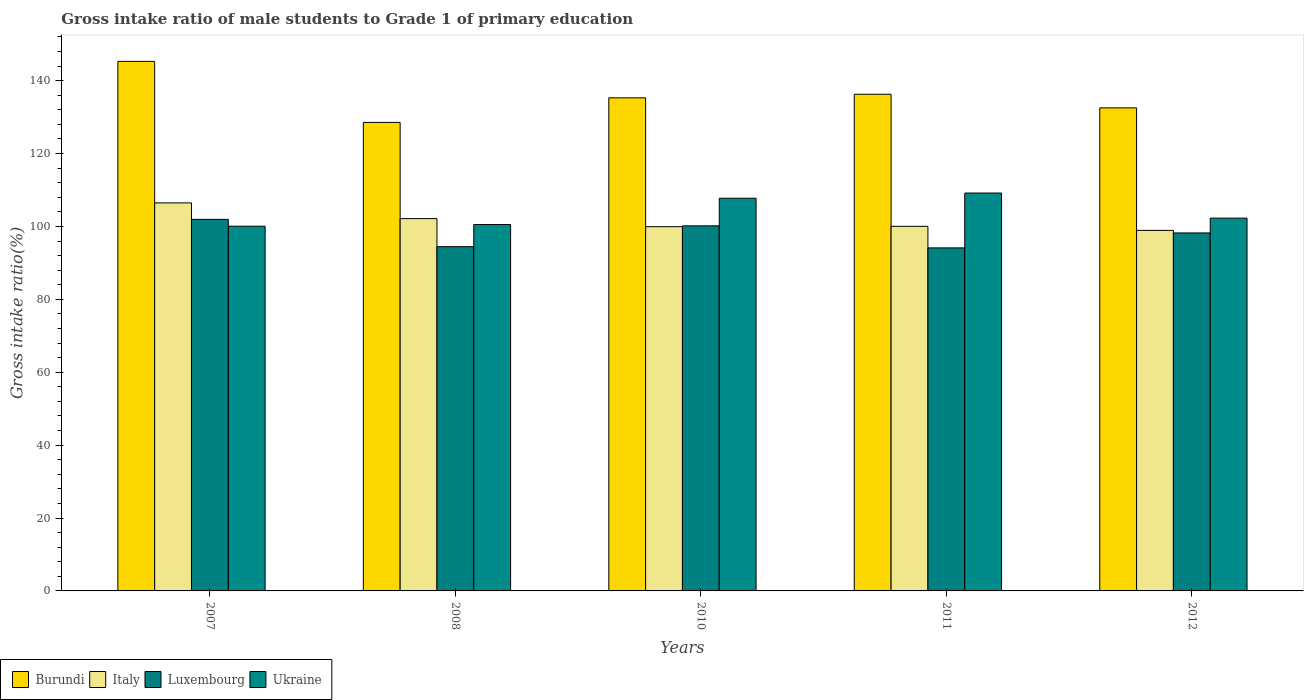How many different coloured bars are there?
Your answer should be very brief. 4. How many groups of bars are there?
Keep it short and to the point. 5. Are the number of bars on each tick of the X-axis equal?
Your answer should be compact. Yes. What is the label of the 5th group of bars from the left?
Your answer should be very brief. 2012. In how many cases, is the number of bars for a given year not equal to the number of legend labels?
Provide a succinct answer. 0. What is the gross intake ratio in Ukraine in 2012?
Give a very brief answer. 102.28. Across all years, what is the maximum gross intake ratio in Burundi?
Your answer should be compact. 145.3. Across all years, what is the minimum gross intake ratio in Burundi?
Make the answer very short. 128.55. In which year was the gross intake ratio in Ukraine maximum?
Offer a very short reply. 2011. In which year was the gross intake ratio in Burundi minimum?
Keep it short and to the point. 2008. What is the total gross intake ratio in Burundi in the graph?
Ensure brevity in your answer.  677.95. What is the difference between the gross intake ratio in Burundi in 2008 and that in 2011?
Offer a very short reply. -7.72. What is the difference between the gross intake ratio in Ukraine in 2008 and the gross intake ratio in Luxembourg in 2012?
Your answer should be compact. 2.3. What is the average gross intake ratio in Ukraine per year?
Your answer should be very brief. 103.96. In the year 2010, what is the difference between the gross intake ratio in Ukraine and gross intake ratio in Italy?
Offer a very short reply. 7.81. In how many years, is the gross intake ratio in Luxembourg greater than 52 %?
Offer a terse response. 5. What is the ratio of the gross intake ratio in Italy in 2010 to that in 2012?
Offer a terse response. 1.01. Is the difference between the gross intake ratio in Ukraine in 2011 and 2012 greater than the difference between the gross intake ratio in Italy in 2011 and 2012?
Provide a succinct answer. Yes. What is the difference between the highest and the second highest gross intake ratio in Burundi?
Your answer should be very brief. 9.03. What is the difference between the highest and the lowest gross intake ratio in Ukraine?
Your response must be concise. 9.1. What does the 2nd bar from the left in 2007 represents?
Provide a succinct answer. Italy. How many bars are there?
Keep it short and to the point. 20. What is the difference between two consecutive major ticks on the Y-axis?
Ensure brevity in your answer.  20. Are the values on the major ticks of Y-axis written in scientific E-notation?
Your answer should be very brief. No. Does the graph contain any zero values?
Make the answer very short. No. Where does the legend appear in the graph?
Your answer should be very brief. Bottom left. What is the title of the graph?
Offer a terse response. Gross intake ratio of male students to Grade 1 of primary education. What is the label or title of the Y-axis?
Give a very brief answer. Gross intake ratio(%). What is the Gross intake ratio(%) of Burundi in 2007?
Your answer should be compact. 145.3. What is the Gross intake ratio(%) in Italy in 2007?
Provide a short and direct response. 106.46. What is the Gross intake ratio(%) of Luxembourg in 2007?
Your answer should be compact. 101.94. What is the Gross intake ratio(%) of Ukraine in 2007?
Ensure brevity in your answer.  100.07. What is the Gross intake ratio(%) of Burundi in 2008?
Offer a terse response. 128.55. What is the Gross intake ratio(%) in Italy in 2008?
Offer a very short reply. 102.15. What is the Gross intake ratio(%) of Luxembourg in 2008?
Offer a very short reply. 94.45. What is the Gross intake ratio(%) in Ukraine in 2008?
Provide a succinct answer. 100.52. What is the Gross intake ratio(%) in Burundi in 2010?
Your response must be concise. 135.29. What is the Gross intake ratio(%) in Italy in 2010?
Provide a short and direct response. 99.94. What is the Gross intake ratio(%) of Luxembourg in 2010?
Provide a short and direct response. 100.16. What is the Gross intake ratio(%) of Ukraine in 2010?
Offer a terse response. 107.74. What is the Gross intake ratio(%) of Burundi in 2011?
Keep it short and to the point. 136.27. What is the Gross intake ratio(%) in Italy in 2011?
Make the answer very short. 100.03. What is the Gross intake ratio(%) in Luxembourg in 2011?
Make the answer very short. 94.12. What is the Gross intake ratio(%) in Ukraine in 2011?
Provide a succinct answer. 109.17. What is the Gross intake ratio(%) of Burundi in 2012?
Give a very brief answer. 132.54. What is the Gross intake ratio(%) of Italy in 2012?
Provide a short and direct response. 98.92. What is the Gross intake ratio(%) in Luxembourg in 2012?
Provide a succinct answer. 98.22. What is the Gross intake ratio(%) of Ukraine in 2012?
Keep it short and to the point. 102.28. Across all years, what is the maximum Gross intake ratio(%) of Burundi?
Your answer should be very brief. 145.3. Across all years, what is the maximum Gross intake ratio(%) of Italy?
Keep it short and to the point. 106.46. Across all years, what is the maximum Gross intake ratio(%) of Luxembourg?
Provide a succinct answer. 101.94. Across all years, what is the maximum Gross intake ratio(%) of Ukraine?
Keep it short and to the point. 109.17. Across all years, what is the minimum Gross intake ratio(%) in Burundi?
Keep it short and to the point. 128.55. Across all years, what is the minimum Gross intake ratio(%) in Italy?
Your answer should be very brief. 98.92. Across all years, what is the minimum Gross intake ratio(%) of Luxembourg?
Ensure brevity in your answer.  94.12. Across all years, what is the minimum Gross intake ratio(%) of Ukraine?
Your answer should be very brief. 100.07. What is the total Gross intake ratio(%) in Burundi in the graph?
Give a very brief answer. 677.95. What is the total Gross intake ratio(%) of Italy in the graph?
Ensure brevity in your answer.  507.5. What is the total Gross intake ratio(%) in Luxembourg in the graph?
Make the answer very short. 488.89. What is the total Gross intake ratio(%) of Ukraine in the graph?
Ensure brevity in your answer.  519.78. What is the difference between the Gross intake ratio(%) of Burundi in 2007 and that in 2008?
Provide a succinct answer. 16.75. What is the difference between the Gross intake ratio(%) in Italy in 2007 and that in 2008?
Keep it short and to the point. 4.31. What is the difference between the Gross intake ratio(%) of Luxembourg in 2007 and that in 2008?
Keep it short and to the point. 7.49. What is the difference between the Gross intake ratio(%) of Ukraine in 2007 and that in 2008?
Make the answer very short. -0.46. What is the difference between the Gross intake ratio(%) in Burundi in 2007 and that in 2010?
Your answer should be compact. 10.01. What is the difference between the Gross intake ratio(%) in Italy in 2007 and that in 2010?
Ensure brevity in your answer.  6.52. What is the difference between the Gross intake ratio(%) in Luxembourg in 2007 and that in 2010?
Your response must be concise. 1.78. What is the difference between the Gross intake ratio(%) of Ukraine in 2007 and that in 2010?
Give a very brief answer. -7.68. What is the difference between the Gross intake ratio(%) of Burundi in 2007 and that in 2011?
Ensure brevity in your answer.  9.03. What is the difference between the Gross intake ratio(%) in Italy in 2007 and that in 2011?
Offer a terse response. 6.43. What is the difference between the Gross intake ratio(%) of Luxembourg in 2007 and that in 2011?
Provide a succinct answer. 7.82. What is the difference between the Gross intake ratio(%) of Ukraine in 2007 and that in 2011?
Offer a terse response. -9.1. What is the difference between the Gross intake ratio(%) of Burundi in 2007 and that in 2012?
Make the answer very short. 12.76. What is the difference between the Gross intake ratio(%) in Italy in 2007 and that in 2012?
Provide a succinct answer. 7.54. What is the difference between the Gross intake ratio(%) of Luxembourg in 2007 and that in 2012?
Offer a very short reply. 3.72. What is the difference between the Gross intake ratio(%) in Ukraine in 2007 and that in 2012?
Make the answer very short. -2.21. What is the difference between the Gross intake ratio(%) of Burundi in 2008 and that in 2010?
Give a very brief answer. -6.74. What is the difference between the Gross intake ratio(%) in Italy in 2008 and that in 2010?
Keep it short and to the point. 2.21. What is the difference between the Gross intake ratio(%) in Luxembourg in 2008 and that in 2010?
Your answer should be compact. -5.72. What is the difference between the Gross intake ratio(%) of Ukraine in 2008 and that in 2010?
Your answer should be compact. -7.22. What is the difference between the Gross intake ratio(%) in Burundi in 2008 and that in 2011?
Your response must be concise. -7.72. What is the difference between the Gross intake ratio(%) of Italy in 2008 and that in 2011?
Keep it short and to the point. 2.12. What is the difference between the Gross intake ratio(%) of Luxembourg in 2008 and that in 2011?
Offer a very short reply. 0.33. What is the difference between the Gross intake ratio(%) of Ukraine in 2008 and that in 2011?
Offer a terse response. -8.64. What is the difference between the Gross intake ratio(%) in Burundi in 2008 and that in 2012?
Make the answer very short. -3.99. What is the difference between the Gross intake ratio(%) of Italy in 2008 and that in 2012?
Your answer should be very brief. 3.23. What is the difference between the Gross intake ratio(%) in Luxembourg in 2008 and that in 2012?
Keep it short and to the point. -3.77. What is the difference between the Gross intake ratio(%) of Ukraine in 2008 and that in 2012?
Your answer should be compact. -1.76. What is the difference between the Gross intake ratio(%) of Burundi in 2010 and that in 2011?
Provide a succinct answer. -0.98. What is the difference between the Gross intake ratio(%) in Italy in 2010 and that in 2011?
Offer a terse response. -0.09. What is the difference between the Gross intake ratio(%) of Luxembourg in 2010 and that in 2011?
Your answer should be compact. 6.05. What is the difference between the Gross intake ratio(%) of Ukraine in 2010 and that in 2011?
Make the answer very short. -1.42. What is the difference between the Gross intake ratio(%) in Burundi in 2010 and that in 2012?
Ensure brevity in your answer.  2.75. What is the difference between the Gross intake ratio(%) of Italy in 2010 and that in 2012?
Ensure brevity in your answer.  1.02. What is the difference between the Gross intake ratio(%) of Luxembourg in 2010 and that in 2012?
Offer a terse response. 1.94. What is the difference between the Gross intake ratio(%) in Ukraine in 2010 and that in 2012?
Your answer should be compact. 5.46. What is the difference between the Gross intake ratio(%) of Burundi in 2011 and that in 2012?
Give a very brief answer. 3.74. What is the difference between the Gross intake ratio(%) of Italy in 2011 and that in 2012?
Make the answer very short. 1.11. What is the difference between the Gross intake ratio(%) of Luxembourg in 2011 and that in 2012?
Keep it short and to the point. -4.1. What is the difference between the Gross intake ratio(%) in Ukraine in 2011 and that in 2012?
Your response must be concise. 6.89. What is the difference between the Gross intake ratio(%) in Burundi in 2007 and the Gross intake ratio(%) in Italy in 2008?
Ensure brevity in your answer.  43.15. What is the difference between the Gross intake ratio(%) of Burundi in 2007 and the Gross intake ratio(%) of Luxembourg in 2008?
Provide a succinct answer. 50.85. What is the difference between the Gross intake ratio(%) in Burundi in 2007 and the Gross intake ratio(%) in Ukraine in 2008?
Make the answer very short. 44.78. What is the difference between the Gross intake ratio(%) in Italy in 2007 and the Gross intake ratio(%) in Luxembourg in 2008?
Offer a very short reply. 12.01. What is the difference between the Gross intake ratio(%) in Italy in 2007 and the Gross intake ratio(%) in Ukraine in 2008?
Provide a succinct answer. 5.94. What is the difference between the Gross intake ratio(%) of Luxembourg in 2007 and the Gross intake ratio(%) of Ukraine in 2008?
Ensure brevity in your answer.  1.42. What is the difference between the Gross intake ratio(%) of Burundi in 2007 and the Gross intake ratio(%) of Italy in 2010?
Give a very brief answer. 45.36. What is the difference between the Gross intake ratio(%) in Burundi in 2007 and the Gross intake ratio(%) in Luxembourg in 2010?
Your answer should be compact. 45.13. What is the difference between the Gross intake ratio(%) of Burundi in 2007 and the Gross intake ratio(%) of Ukraine in 2010?
Offer a terse response. 37.56. What is the difference between the Gross intake ratio(%) of Italy in 2007 and the Gross intake ratio(%) of Luxembourg in 2010?
Give a very brief answer. 6.3. What is the difference between the Gross intake ratio(%) in Italy in 2007 and the Gross intake ratio(%) in Ukraine in 2010?
Give a very brief answer. -1.28. What is the difference between the Gross intake ratio(%) in Luxembourg in 2007 and the Gross intake ratio(%) in Ukraine in 2010?
Give a very brief answer. -5.8. What is the difference between the Gross intake ratio(%) of Burundi in 2007 and the Gross intake ratio(%) of Italy in 2011?
Your answer should be compact. 45.27. What is the difference between the Gross intake ratio(%) of Burundi in 2007 and the Gross intake ratio(%) of Luxembourg in 2011?
Provide a short and direct response. 51.18. What is the difference between the Gross intake ratio(%) in Burundi in 2007 and the Gross intake ratio(%) in Ukraine in 2011?
Give a very brief answer. 36.13. What is the difference between the Gross intake ratio(%) in Italy in 2007 and the Gross intake ratio(%) in Luxembourg in 2011?
Offer a very short reply. 12.34. What is the difference between the Gross intake ratio(%) in Italy in 2007 and the Gross intake ratio(%) in Ukraine in 2011?
Offer a very short reply. -2.71. What is the difference between the Gross intake ratio(%) of Luxembourg in 2007 and the Gross intake ratio(%) of Ukraine in 2011?
Offer a very short reply. -7.23. What is the difference between the Gross intake ratio(%) in Burundi in 2007 and the Gross intake ratio(%) in Italy in 2012?
Give a very brief answer. 46.38. What is the difference between the Gross intake ratio(%) in Burundi in 2007 and the Gross intake ratio(%) in Luxembourg in 2012?
Your answer should be compact. 47.08. What is the difference between the Gross intake ratio(%) in Burundi in 2007 and the Gross intake ratio(%) in Ukraine in 2012?
Your answer should be very brief. 43.02. What is the difference between the Gross intake ratio(%) of Italy in 2007 and the Gross intake ratio(%) of Luxembourg in 2012?
Provide a short and direct response. 8.24. What is the difference between the Gross intake ratio(%) in Italy in 2007 and the Gross intake ratio(%) in Ukraine in 2012?
Provide a succinct answer. 4.18. What is the difference between the Gross intake ratio(%) in Luxembourg in 2007 and the Gross intake ratio(%) in Ukraine in 2012?
Provide a short and direct response. -0.34. What is the difference between the Gross intake ratio(%) in Burundi in 2008 and the Gross intake ratio(%) in Italy in 2010?
Offer a very short reply. 28.61. What is the difference between the Gross intake ratio(%) of Burundi in 2008 and the Gross intake ratio(%) of Luxembourg in 2010?
Your answer should be very brief. 28.39. What is the difference between the Gross intake ratio(%) in Burundi in 2008 and the Gross intake ratio(%) in Ukraine in 2010?
Offer a very short reply. 20.81. What is the difference between the Gross intake ratio(%) in Italy in 2008 and the Gross intake ratio(%) in Luxembourg in 2010?
Provide a succinct answer. 1.99. What is the difference between the Gross intake ratio(%) in Italy in 2008 and the Gross intake ratio(%) in Ukraine in 2010?
Give a very brief answer. -5.59. What is the difference between the Gross intake ratio(%) in Luxembourg in 2008 and the Gross intake ratio(%) in Ukraine in 2010?
Give a very brief answer. -13.29. What is the difference between the Gross intake ratio(%) of Burundi in 2008 and the Gross intake ratio(%) of Italy in 2011?
Make the answer very short. 28.52. What is the difference between the Gross intake ratio(%) of Burundi in 2008 and the Gross intake ratio(%) of Luxembourg in 2011?
Ensure brevity in your answer.  34.43. What is the difference between the Gross intake ratio(%) in Burundi in 2008 and the Gross intake ratio(%) in Ukraine in 2011?
Provide a short and direct response. 19.38. What is the difference between the Gross intake ratio(%) in Italy in 2008 and the Gross intake ratio(%) in Luxembourg in 2011?
Provide a succinct answer. 8.03. What is the difference between the Gross intake ratio(%) in Italy in 2008 and the Gross intake ratio(%) in Ukraine in 2011?
Provide a short and direct response. -7.01. What is the difference between the Gross intake ratio(%) in Luxembourg in 2008 and the Gross intake ratio(%) in Ukraine in 2011?
Provide a succinct answer. -14.72. What is the difference between the Gross intake ratio(%) in Burundi in 2008 and the Gross intake ratio(%) in Italy in 2012?
Offer a terse response. 29.63. What is the difference between the Gross intake ratio(%) in Burundi in 2008 and the Gross intake ratio(%) in Luxembourg in 2012?
Provide a succinct answer. 30.33. What is the difference between the Gross intake ratio(%) of Burundi in 2008 and the Gross intake ratio(%) of Ukraine in 2012?
Ensure brevity in your answer.  26.27. What is the difference between the Gross intake ratio(%) in Italy in 2008 and the Gross intake ratio(%) in Luxembourg in 2012?
Provide a short and direct response. 3.93. What is the difference between the Gross intake ratio(%) of Italy in 2008 and the Gross intake ratio(%) of Ukraine in 2012?
Keep it short and to the point. -0.13. What is the difference between the Gross intake ratio(%) in Luxembourg in 2008 and the Gross intake ratio(%) in Ukraine in 2012?
Offer a terse response. -7.83. What is the difference between the Gross intake ratio(%) in Burundi in 2010 and the Gross intake ratio(%) in Italy in 2011?
Offer a very short reply. 35.26. What is the difference between the Gross intake ratio(%) in Burundi in 2010 and the Gross intake ratio(%) in Luxembourg in 2011?
Offer a terse response. 41.17. What is the difference between the Gross intake ratio(%) of Burundi in 2010 and the Gross intake ratio(%) of Ukraine in 2011?
Make the answer very short. 26.12. What is the difference between the Gross intake ratio(%) of Italy in 2010 and the Gross intake ratio(%) of Luxembourg in 2011?
Your answer should be compact. 5.82. What is the difference between the Gross intake ratio(%) in Italy in 2010 and the Gross intake ratio(%) in Ukraine in 2011?
Your answer should be very brief. -9.23. What is the difference between the Gross intake ratio(%) in Luxembourg in 2010 and the Gross intake ratio(%) in Ukraine in 2011?
Ensure brevity in your answer.  -9. What is the difference between the Gross intake ratio(%) in Burundi in 2010 and the Gross intake ratio(%) in Italy in 2012?
Ensure brevity in your answer.  36.37. What is the difference between the Gross intake ratio(%) in Burundi in 2010 and the Gross intake ratio(%) in Luxembourg in 2012?
Offer a terse response. 37.07. What is the difference between the Gross intake ratio(%) in Burundi in 2010 and the Gross intake ratio(%) in Ukraine in 2012?
Ensure brevity in your answer.  33.01. What is the difference between the Gross intake ratio(%) of Italy in 2010 and the Gross intake ratio(%) of Luxembourg in 2012?
Provide a succinct answer. 1.72. What is the difference between the Gross intake ratio(%) in Italy in 2010 and the Gross intake ratio(%) in Ukraine in 2012?
Offer a terse response. -2.34. What is the difference between the Gross intake ratio(%) of Luxembourg in 2010 and the Gross intake ratio(%) of Ukraine in 2012?
Your answer should be very brief. -2.12. What is the difference between the Gross intake ratio(%) in Burundi in 2011 and the Gross intake ratio(%) in Italy in 2012?
Provide a short and direct response. 37.35. What is the difference between the Gross intake ratio(%) of Burundi in 2011 and the Gross intake ratio(%) of Luxembourg in 2012?
Your answer should be compact. 38.05. What is the difference between the Gross intake ratio(%) of Burundi in 2011 and the Gross intake ratio(%) of Ukraine in 2012?
Make the answer very short. 33.99. What is the difference between the Gross intake ratio(%) in Italy in 2011 and the Gross intake ratio(%) in Luxembourg in 2012?
Ensure brevity in your answer.  1.81. What is the difference between the Gross intake ratio(%) in Italy in 2011 and the Gross intake ratio(%) in Ukraine in 2012?
Provide a short and direct response. -2.25. What is the difference between the Gross intake ratio(%) in Luxembourg in 2011 and the Gross intake ratio(%) in Ukraine in 2012?
Keep it short and to the point. -8.16. What is the average Gross intake ratio(%) in Burundi per year?
Keep it short and to the point. 135.59. What is the average Gross intake ratio(%) in Italy per year?
Your answer should be compact. 101.5. What is the average Gross intake ratio(%) in Luxembourg per year?
Offer a very short reply. 97.78. What is the average Gross intake ratio(%) in Ukraine per year?
Ensure brevity in your answer.  103.96. In the year 2007, what is the difference between the Gross intake ratio(%) of Burundi and Gross intake ratio(%) of Italy?
Give a very brief answer. 38.84. In the year 2007, what is the difference between the Gross intake ratio(%) in Burundi and Gross intake ratio(%) in Luxembourg?
Provide a short and direct response. 43.36. In the year 2007, what is the difference between the Gross intake ratio(%) in Burundi and Gross intake ratio(%) in Ukraine?
Provide a short and direct response. 45.23. In the year 2007, what is the difference between the Gross intake ratio(%) of Italy and Gross intake ratio(%) of Luxembourg?
Keep it short and to the point. 4.52. In the year 2007, what is the difference between the Gross intake ratio(%) in Italy and Gross intake ratio(%) in Ukraine?
Your response must be concise. 6.39. In the year 2007, what is the difference between the Gross intake ratio(%) in Luxembourg and Gross intake ratio(%) in Ukraine?
Give a very brief answer. 1.87. In the year 2008, what is the difference between the Gross intake ratio(%) in Burundi and Gross intake ratio(%) in Italy?
Provide a succinct answer. 26.4. In the year 2008, what is the difference between the Gross intake ratio(%) of Burundi and Gross intake ratio(%) of Luxembourg?
Provide a succinct answer. 34.1. In the year 2008, what is the difference between the Gross intake ratio(%) of Burundi and Gross intake ratio(%) of Ukraine?
Make the answer very short. 28.03. In the year 2008, what is the difference between the Gross intake ratio(%) in Italy and Gross intake ratio(%) in Luxembourg?
Your answer should be compact. 7.7. In the year 2008, what is the difference between the Gross intake ratio(%) of Italy and Gross intake ratio(%) of Ukraine?
Give a very brief answer. 1.63. In the year 2008, what is the difference between the Gross intake ratio(%) in Luxembourg and Gross intake ratio(%) in Ukraine?
Provide a short and direct response. -6.07. In the year 2010, what is the difference between the Gross intake ratio(%) in Burundi and Gross intake ratio(%) in Italy?
Your response must be concise. 35.35. In the year 2010, what is the difference between the Gross intake ratio(%) in Burundi and Gross intake ratio(%) in Luxembourg?
Give a very brief answer. 35.13. In the year 2010, what is the difference between the Gross intake ratio(%) of Burundi and Gross intake ratio(%) of Ukraine?
Offer a very short reply. 27.55. In the year 2010, what is the difference between the Gross intake ratio(%) of Italy and Gross intake ratio(%) of Luxembourg?
Offer a very short reply. -0.23. In the year 2010, what is the difference between the Gross intake ratio(%) of Italy and Gross intake ratio(%) of Ukraine?
Offer a terse response. -7.8. In the year 2010, what is the difference between the Gross intake ratio(%) in Luxembourg and Gross intake ratio(%) in Ukraine?
Provide a short and direct response. -7.58. In the year 2011, what is the difference between the Gross intake ratio(%) in Burundi and Gross intake ratio(%) in Italy?
Your response must be concise. 36.24. In the year 2011, what is the difference between the Gross intake ratio(%) in Burundi and Gross intake ratio(%) in Luxembourg?
Offer a very short reply. 42.16. In the year 2011, what is the difference between the Gross intake ratio(%) in Burundi and Gross intake ratio(%) in Ukraine?
Your response must be concise. 27.11. In the year 2011, what is the difference between the Gross intake ratio(%) in Italy and Gross intake ratio(%) in Luxembourg?
Offer a very short reply. 5.91. In the year 2011, what is the difference between the Gross intake ratio(%) of Italy and Gross intake ratio(%) of Ukraine?
Provide a succinct answer. -9.14. In the year 2011, what is the difference between the Gross intake ratio(%) of Luxembourg and Gross intake ratio(%) of Ukraine?
Keep it short and to the point. -15.05. In the year 2012, what is the difference between the Gross intake ratio(%) of Burundi and Gross intake ratio(%) of Italy?
Ensure brevity in your answer.  33.62. In the year 2012, what is the difference between the Gross intake ratio(%) of Burundi and Gross intake ratio(%) of Luxembourg?
Ensure brevity in your answer.  34.32. In the year 2012, what is the difference between the Gross intake ratio(%) of Burundi and Gross intake ratio(%) of Ukraine?
Offer a terse response. 30.26. In the year 2012, what is the difference between the Gross intake ratio(%) in Italy and Gross intake ratio(%) in Luxembourg?
Ensure brevity in your answer.  0.7. In the year 2012, what is the difference between the Gross intake ratio(%) of Italy and Gross intake ratio(%) of Ukraine?
Offer a very short reply. -3.36. In the year 2012, what is the difference between the Gross intake ratio(%) in Luxembourg and Gross intake ratio(%) in Ukraine?
Ensure brevity in your answer.  -4.06. What is the ratio of the Gross intake ratio(%) in Burundi in 2007 to that in 2008?
Offer a very short reply. 1.13. What is the ratio of the Gross intake ratio(%) of Italy in 2007 to that in 2008?
Ensure brevity in your answer.  1.04. What is the ratio of the Gross intake ratio(%) of Luxembourg in 2007 to that in 2008?
Offer a terse response. 1.08. What is the ratio of the Gross intake ratio(%) of Burundi in 2007 to that in 2010?
Provide a succinct answer. 1.07. What is the ratio of the Gross intake ratio(%) of Italy in 2007 to that in 2010?
Provide a succinct answer. 1.07. What is the ratio of the Gross intake ratio(%) in Luxembourg in 2007 to that in 2010?
Provide a short and direct response. 1.02. What is the ratio of the Gross intake ratio(%) in Ukraine in 2007 to that in 2010?
Keep it short and to the point. 0.93. What is the ratio of the Gross intake ratio(%) in Burundi in 2007 to that in 2011?
Keep it short and to the point. 1.07. What is the ratio of the Gross intake ratio(%) in Italy in 2007 to that in 2011?
Your answer should be compact. 1.06. What is the ratio of the Gross intake ratio(%) in Luxembourg in 2007 to that in 2011?
Your answer should be very brief. 1.08. What is the ratio of the Gross intake ratio(%) of Ukraine in 2007 to that in 2011?
Give a very brief answer. 0.92. What is the ratio of the Gross intake ratio(%) in Burundi in 2007 to that in 2012?
Your answer should be compact. 1.1. What is the ratio of the Gross intake ratio(%) in Italy in 2007 to that in 2012?
Make the answer very short. 1.08. What is the ratio of the Gross intake ratio(%) of Luxembourg in 2007 to that in 2012?
Offer a very short reply. 1.04. What is the ratio of the Gross intake ratio(%) in Ukraine in 2007 to that in 2012?
Make the answer very short. 0.98. What is the ratio of the Gross intake ratio(%) of Burundi in 2008 to that in 2010?
Your response must be concise. 0.95. What is the ratio of the Gross intake ratio(%) of Italy in 2008 to that in 2010?
Provide a succinct answer. 1.02. What is the ratio of the Gross intake ratio(%) of Luxembourg in 2008 to that in 2010?
Ensure brevity in your answer.  0.94. What is the ratio of the Gross intake ratio(%) of Ukraine in 2008 to that in 2010?
Provide a succinct answer. 0.93. What is the ratio of the Gross intake ratio(%) of Burundi in 2008 to that in 2011?
Provide a short and direct response. 0.94. What is the ratio of the Gross intake ratio(%) in Italy in 2008 to that in 2011?
Offer a terse response. 1.02. What is the ratio of the Gross intake ratio(%) of Luxembourg in 2008 to that in 2011?
Provide a short and direct response. 1. What is the ratio of the Gross intake ratio(%) in Ukraine in 2008 to that in 2011?
Keep it short and to the point. 0.92. What is the ratio of the Gross intake ratio(%) of Burundi in 2008 to that in 2012?
Make the answer very short. 0.97. What is the ratio of the Gross intake ratio(%) in Italy in 2008 to that in 2012?
Make the answer very short. 1.03. What is the ratio of the Gross intake ratio(%) of Luxembourg in 2008 to that in 2012?
Keep it short and to the point. 0.96. What is the ratio of the Gross intake ratio(%) of Ukraine in 2008 to that in 2012?
Provide a short and direct response. 0.98. What is the ratio of the Gross intake ratio(%) in Italy in 2010 to that in 2011?
Your response must be concise. 1. What is the ratio of the Gross intake ratio(%) of Luxembourg in 2010 to that in 2011?
Offer a very short reply. 1.06. What is the ratio of the Gross intake ratio(%) of Ukraine in 2010 to that in 2011?
Make the answer very short. 0.99. What is the ratio of the Gross intake ratio(%) of Burundi in 2010 to that in 2012?
Your answer should be compact. 1.02. What is the ratio of the Gross intake ratio(%) of Italy in 2010 to that in 2012?
Provide a short and direct response. 1.01. What is the ratio of the Gross intake ratio(%) in Luxembourg in 2010 to that in 2012?
Your answer should be compact. 1.02. What is the ratio of the Gross intake ratio(%) in Ukraine in 2010 to that in 2012?
Your response must be concise. 1.05. What is the ratio of the Gross intake ratio(%) of Burundi in 2011 to that in 2012?
Make the answer very short. 1.03. What is the ratio of the Gross intake ratio(%) of Italy in 2011 to that in 2012?
Your response must be concise. 1.01. What is the ratio of the Gross intake ratio(%) of Luxembourg in 2011 to that in 2012?
Offer a very short reply. 0.96. What is the ratio of the Gross intake ratio(%) of Ukraine in 2011 to that in 2012?
Keep it short and to the point. 1.07. What is the difference between the highest and the second highest Gross intake ratio(%) in Burundi?
Make the answer very short. 9.03. What is the difference between the highest and the second highest Gross intake ratio(%) of Italy?
Give a very brief answer. 4.31. What is the difference between the highest and the second highest Gross intake ratio(%) in Luxembourg?
Provide a succinct answer. 1.78. What is the difference between the highest and the second highest Gross intake ratio(%) of Ukraine?
Offer a very short reply. 1.42. What is the difference between the highest and the lowest Gross intake ratio(%) of Burundi?
Your response must be concise. 16.75. What is the difference between the highest and the lowest Gross intake ratio(%) in Italy?
Give a very brief answer. 7.54. What is the difference between the highest and the lowest Gross intake ratio(%) in Luxembourg?
Keep it short and to the point. 7.82. What is the difference between the highest and the lowest Gross intake ratio(%) in Ukraine?
Offer a terse response. 9.1. 